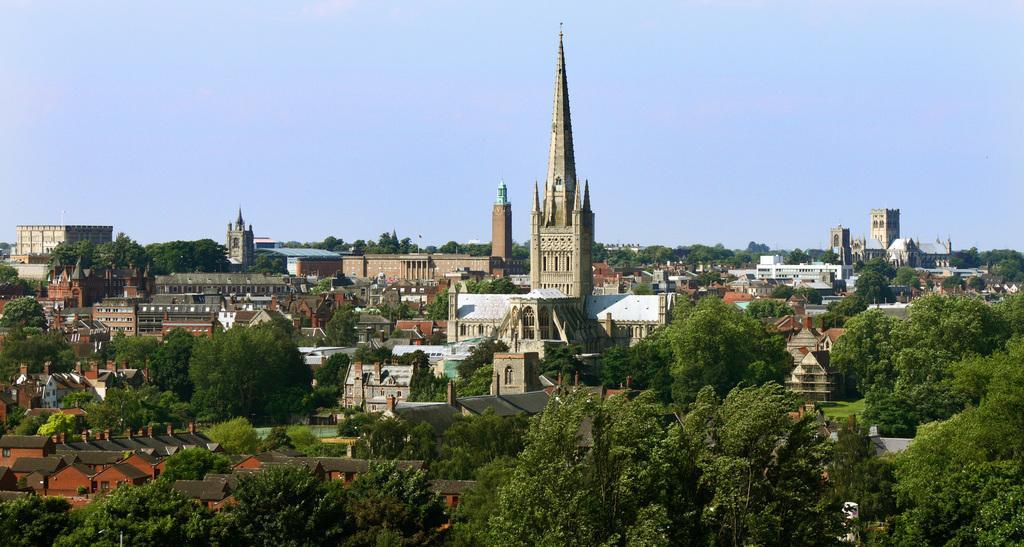Please provide a concise description of this image. In this image there are buildings, trees and at the background there is sky. 